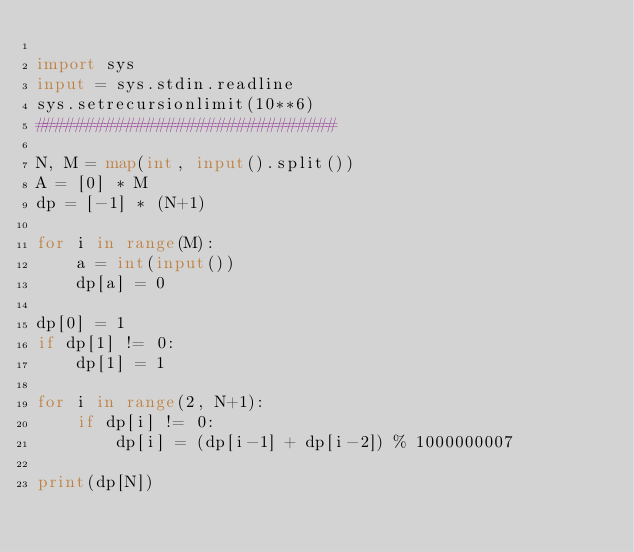<code> <loc_0><loc_0><loc_500><loc_500><_Python_>
import sys
input = sys.stdin.readline
sys.setrecursionlimit(10**6)
##############################

N, M = map(int, input().split())
A = [0] * M
dp = [-1] * (N+1)

for i in range(M):
    a = int(input())
    dp[a] = 0

dp[0] = 1
if dp[1] != 0:
    dp[1] = 1

for i in range(2, N+1):
    if dp[i] != 0:
        dp[i] = (dp[i-1] + dp[i-2]) % 1000000007

print(dp[N])
</code> 